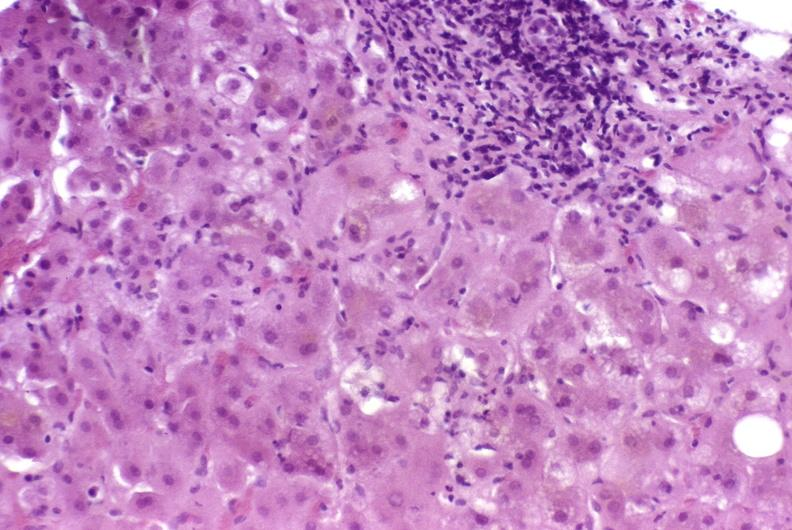s metastatic carcinoma prostate present?
Answer the question using a single word or phrase. No 